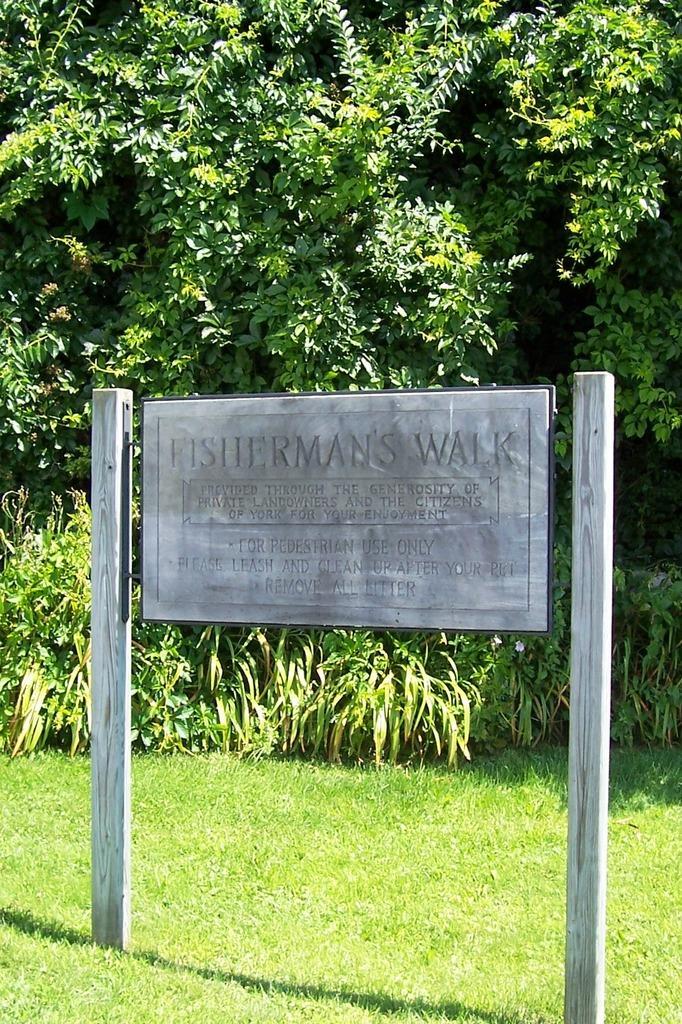How would you summarize this image in a sentence or two? In the image we can see there is a hoarding kept on the wall and the ground is covered with grass. It's written ¨FISHERMAN'S WALK¨ on the hoarding. Behind there are plants on the ground and there are trees. 